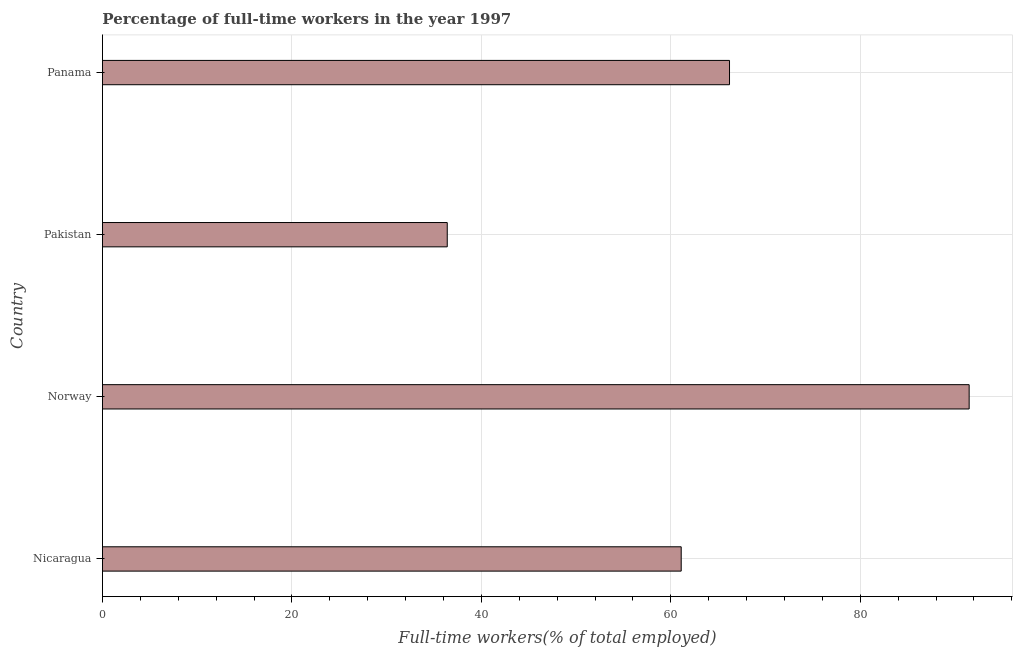Does the graph contain any zero values?
Your response must be concise. No. Does the graph contain grids?
Your response must be concise. Yes. What is the title of the graph?
Offer a terse response. Percentage of full-time workers in the year 1997. What is the label or title of the X-axis?
Your response must be concise. Full-time workers(% of total employed). What is the percentage of full-time workers in Nicaragua?
Provide a short and direct response. 61.1. Across all countries, what is the maximum percentage of full-time workers?
Your answer should be compact. 91.5. Across all countries, what is the minimum percentage of full-time workers?
Keep it short and to the point. 36.4. What is the sum of the percentage of full-time workers?
Provide a short and direct response. 255.2. What is the difference between the percentage of full-time workers in Nicaragua and Norway?
Provide a short and direct response. -30.4. What is the average percentage of full-time workers per country?
Offer a terse response. 63.8. What is the median percentage of full-time workers?
Your answer should be very brief. 63.65. In how many countries, is the percentage of full-time workers greater than 52 %?
Ensure brevity in your answer.  3. What is the ratio of the percentage of full-time workers in Norway to that in Pakistan?
Your answer should be very brief. 2.51. Is the difference between the percentage of full-time workers in Norway and Pakistan greater than the difference between any two countries?
Your response must be concise. Yes. What is the difference between the highest and the second highest percentage of full-time workers?
Keep it short and to the point. 25.3. Is the sum of the percentage of full-time workers in Pakistan and Panama greater than the maximum percentage of full-time workers across all countries?
Make the answer very short. Yes. What is the difference between the highest and the lowest percentage of full-time workers?
Provide a succinct answer. 55.1. How many bars are there?
Your response must be concise. 4. What is the difference between two consecutive major ticks on the X-axis?
Give a very brief answer. 20. Are the values on the major ticks of X-axis written in scientific E-notation?
Offer a terse response. No. What is the Full-time workers(% of total employed) of Nicaragua?
Give a very brief answer. 61.1. What is the Full-time workers(% of total employed) of Norway?
Provide a short and direct response. 91.5. What is the Full-time workers(% of total employed) of Pakistan?
Provide a succinct answer. 36.4. What is the Full-time workers(% of total employed) of Panama?
Provide a succinct answer. 66.2. What is the difference between the Full-time workers(% of total employed) in Nicaragua and Norway?
Keep it short and to the point. -30.4. What is the difference between the Full-time workers(% of total employed) in Nicaragua and Pakistan?
Your answer should be very brief. 24.7. What is the difference between the Full-time workers(% of total employed) in Norway and Pakistan?
Ensure brevity in your answer.  55.1. What is the difference between the Full-time workers(% of total employed) in Norway and Panama?
Make the answer very short. 25.3. What is the difference between the Full-time workers(% of total employed) in Pakistan and Panama?
Your response must be concise. -29.8. What is the ratio of the Full-time workers(% of total employed) in Nicaragua to that in Norway?
Give a very brief answer. 0.67. What is the ratio of the Full-time workers(% of total employed) in Nicaragua to that in Pakistan?
Make the answer very short. 1.68. What is the ratio of the Full-time workers(% of total employed) in Nicaragua to that in Panama?
Offer a terse response. 0.92. What is the ratio of the Full-time workers(% of total employed) in Norway to that in Pakistan?
Keep it short and to the point. 2.51. What is the ratio of the Full-time workers(% of total employed) in Norway to that in Panama?
Give a very brief answer. 1.38. What is the ratio of the Full-time workers(% of total employed) in Pakistan to that in Panama?
Keep it short and to the point. 0.55. 